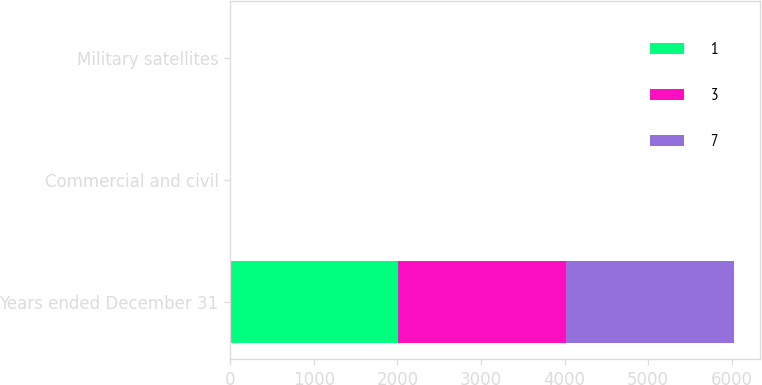Convert chart. <chart><loc_0><loc_0><loc_500><loc_500><stacked_bar_chart><ecel><fcel>Years ended December 31<fcel>Commercial and civil<fcel>Military satellites<nl><fcel>1<fcel>2012<fcel>3<fcel>7<nl><fcel>3<fcel>2011<fcel>1<fcel>3<nl><fcel>7<fcel>2010<fcel>3<fcel>1<nl></chart> 